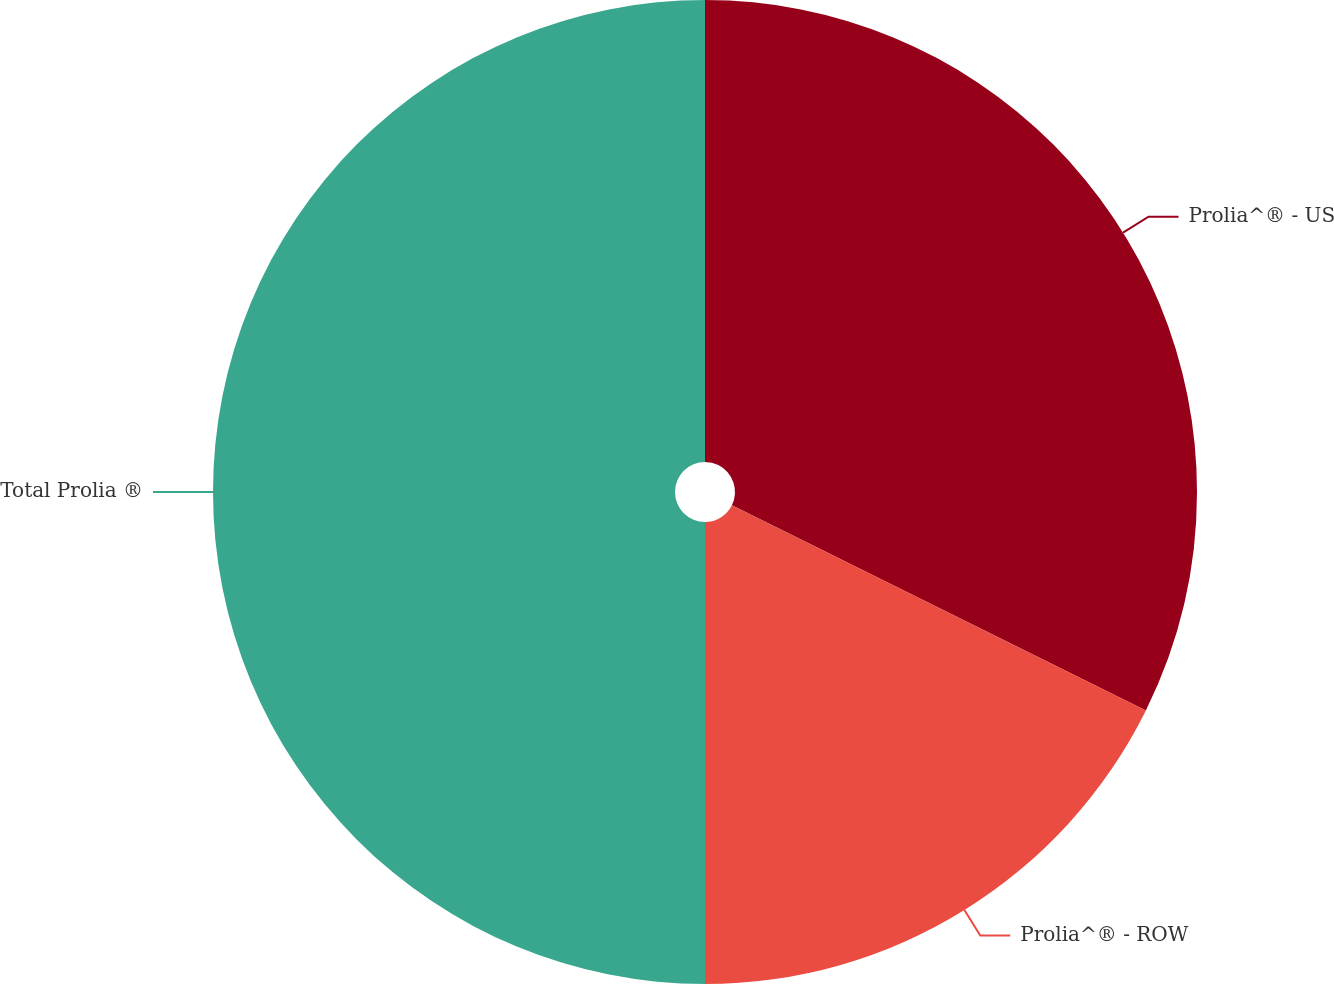Convert chart. <chart><loc_0><loc_0><loc_500><loc_500><pie_chart><fcel>Prolia^® - US<fcel>Prolia^® - ROW<fcel>Total Prolia ®<nl><fcel>32.32%<fcel>17.68%<fcel>50.0%<nl></chart> 